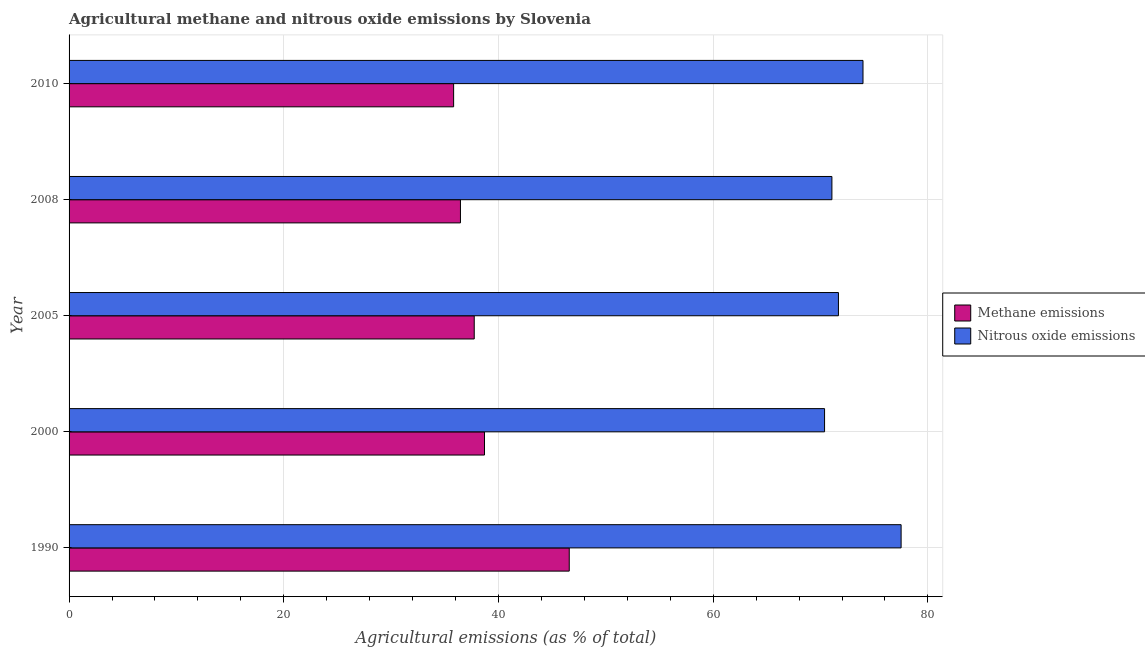How many different coloured bars are there?
Your answer should be very brief. 2. How many groups of bars are there?
Your answer should be compact. 5. Are the number of bars per tick equal to the number of legend labels?
Your answer should be compact. Yes. Are the number of bars on each tick of the Y-axis equal?
Make the answer very short. Yes. How many bars are there on the 2nd tick from the bottom?
Your answer should be compact. 2. What is the amount of methane emissions in 2005?
Make the answer very short. 37.74. Across all years, what is the maximum amount of methane emissions?
Offer a terse response. 46.59. Across all years, what is the minimum amount of nitrous oxide emissions?
Your response must be concise. 70.37. In which year was the amount of methane emissions maximum?
Ensure brevity in your answer.  1990. In which year was the amount of nitrous oxide emissions minimum?
Make the answer very short. 2000. What is the total amount of methane emissions in the graph?
Ensure brevity in your answer.  195.3. What is the difference between the amount of nitrous oxide emissions in 2000 and that in 2008?
Ensure brevity in your answer.  -0.69. What is the difference between the amount of nitrous oxide emissions in 2005 and the amount of methane emissions in 2008?
Keep it short and to the point. 35.21. What is the average amount of nitrous oxide emissions per year?
Give a very brief answer. 72.91. In the year 2000, what is the difference between the amount of methane emissions and amount of nitrous oxide emissions?
Ensure brevity in your answer.  -31.68. What is the ratio of the amount of methane emissions in 1990 to that in 2010?
Give a very brief answer. 1.3. What is the difference between the highest and the second highest amount of nitrous oxide emissions?
Keep it short and to the point. 3.55. What is the difference between the highest and the lowest amount of methane emissions?
Provide a succinct answer. 10.77. What does the 1st bar from the top in 1990 represents?
Your response must be concise. Nitrous oxide emissions. What does the 1st bar from the bottom in 2008 represents?
Keep it short and to the point. Methane emissions. How many years are there in the graph?
Provide a succinct answer. 5. What is the difference between two consecutive major ticks on the X-axis?
Provide a succinct answer. 20. Are the values on the major ticks of X-axis written in scientific E-notation?
Provide a succinct answer. No. Does the graph contain any zero values?
Provide a succinct answer. No. Where does the legend appear in the graph?
Your answer should be compact. Center right. How many legend labels are there?
Your response must be concise. 2. What is the title of the graph?
Keep it short and to the point. Agricultural methane and nitrous oxide emissions by Slovenia. Does "Register a business" appear as one of the legend labels in the graph?
Ensure brevity in your answer.  No. What is the label or title of the X-axis?
Offer a very short reply. Agricultural emissions (as % of total). What is the Agricultural emissions (as % of total) of Methane emissions in 1990?
Keep it short and to the point. 46.59. What is the Agricultural emissions (as % of total) in Nitrous oxide emissions in 1990?
Your answer should be compact. 77.5. What is the Agricultural emissions (as % of total) of Methane emissions in 2000?
Your response must be concise. 38.7. What is the Agricultural emissions (as % of total) of Nitrous oxide emissions in 2000?
Offer a very short reply. 70.37. What is the Agricultural emissions (as % of total) in Methane emissions in 2005?
Your answer should be very brief. 37.74. What is the Agricultural emissions (as % of total) in Nitrous oxide emissions in 2005?
Offer a very short reply. 71.67. What is the Agricultural emissions (as % of total) of Methane emissions in 2008?
Give a very brief answer. 36.46. What is the Agricultural emissions (as % of total) of Nitrous oxide emissions in 2008?
Your answer should be very brief. 71.06. What is the Agricultural emissions (as % of total) of Methane emissions in 2010?
Provide a short and direct response. 35.82. What is the Agricultural emissions (as % of total) of Nitrous oxide emissions in 2010?
Make the answer very short. 73.95. Across all years, what is the maximum Agricultural emissions (as % of total) of Methane emissions?
Your answer should be very brief. 46.59. Across all years, what is the maximum Agricultural emissions (as % of total) of Nitrous oxide emissions?
Keep it short and to the point. 77.5. Across all years, what is the minimum Agricultural emissions (as % of total) in Methane emissions?
Your response must be concise. 35.82. Across all years, what is the minimum Agricultural emissions (as % of total) in Nitrous oxide emissions?
Ensure brevity in your answer.  70.37. What is the total Agricultural emissions (as % of total) of Methane emissions in the graph?
Provide a short and direct response. 195.3. What is the total Agricultural emissions (as % of total) in Nitrous oxide emissions in the graph?
Offer a terse response. 364.55. What is the difference between the Agricultural emissions (as % of total) in Methane emissions in 1990 and that in 2000?
Your answer should be very brief. 7.89. What is the difference between the Agricultural emissions (as % of total) of Nitrous oxide emissions in 1990 and that in 2000?
Offer a very short reply. 7.13. What is the difference between the Agricultural emissions (as % of total) of Methane emissions in 1990 and that in 2005?
Provide a succinct answer. 8.85. What is the difference between the Agricultural emissions (as % of total) in Nitrous oxide emissions in 1990 and that in 2005?
Ensure brevity in your answer.  5.84. What is the difference between the Agricultural emissions (as % of total) of Methane emissions in 1990 and that in 2008?
Provide a succinct answer. 10.13. What is the difference between the Agricultural emissions (as % of total) in Nitrous oxide emissions in 1990 and that in 2008?
Provide a succinct answer. 6.45. What is the difference between the Agricultural emissions (as % of total) of Methane emissions in 1990 and that in 2010?
Offer a terse response. 10.77. What is the difference between the Agricultural emissions (as % of total) in Nitrous oxide emissions in 1990 and that in 2010?
Offer a very short reply. 3.55. What is the difference between the Agricultural emissions (as % of total) in Methane emissions in 2000 and that in 2005?
Offer a terse response. 0.96. What is the difference between the Agricultural emissions (as % of total) in Nitrous oxide emissions in 2000 and that in 2005?
Offer a terse response. -1.29. What is the difference between the Agricultural emissions (as % of total) of Methane emissions in 2000 and that in 2008?
Give a very brief answer. 2.24. What is the difference between the Agricultural emissions (as % of total) of Nitrous oxide emissions in 2000 and that in 2008?
Offer a very short reply. -0.68. What is the difference between the Agricultural emissions (as % of total) in Methane emissions in 2000 and that in 2010?
Provide a succinct answer. 2.88. What is the difference between the Agricultural emissions (as % of total) of Nitrous oxide emissions in 2000 and that in 2010?
Give a very brief answer. -3.58. What is the difference between the Agricultural emissions (as % of total) of Methane emissions in 2005 and that in 2008?
Keep it short and to the point. 1.28. What is the difference between the Agricultural emissions (as % of total) of Nitrous oxide emissions in 2005 and that in 2008?
Your answer should be very brief. 0.61. What is the difference between the Agricultural emissions (as % of total) in Methane emissions in 2005 and that in 2010?
Make the answer very short. 1.92. What is the difference between the Agricultural emissions (as % of total) of Nitrous oxide emissions in 2005 and that in 2010?
Your answer should be compact. -2.29. What is the difference between the Agricultural emissions (as % of total) of Methane emissions in 2008 and that in 2010?
Keep it short and to the point. 0.64. What is the difference between the Agricultural emissions (as % of total) of Nitrous oxide emissions in 2008 and that in 2010?
Keep it short and to the point. -2.9. What is the difference between the Agricultural emissions (as % of total) of Methane emissions in 1990 and the Agricultural emissions (as % of total) of Nitrous oxide emissions in 2000?
Your answer should be very brief. -23.78. What is the difference between the Agricultural emissions (as % of total) in Methane emissions in 1990 and the Agricultural emissions (as % of total) in Nitrous oxide emissions in 2005?
Provide a succinct answer. -25.07. What is the difference between the Agricultural emissions (as % of total) in Methane emissions in 1990 and the Agricultural emissions (as % of total) in Nitrous oxide emissions in 2008?
Ensure brevity in your answer.  -24.47. What is the difference between the Agricultural emissions (as % of total) of Methane emissions in 1990 and the Agricultural emissions (as % of total) of Nitrous oxide emissions in 2010?
Your answer should be very brief. -27.36. What is the difference between the Agricultural emissions (as % of total) of Methane emissions in 2000 and the Agricultural emissions (as % of total) of Nitrous oxide emissions in 2005?
Your answer should be compact. -32.97. What is the difference between the Agricultural emissions (as % of total) in Methane emissions in 2000 and the Agricultural emissions (as % of total) in Nitrous oxide emissions in 2008?
Keep it short and to the point. -32.36. What is the difference between the Agricultural emissions (as % of total) in Methane emissions in 2000 and the Agricultural emissions (as % of total) in Nitrous oxide emissions in 2010?
Provide a succinct answer. -35.26. What is the difference between the Agricultural emissions (as % of total) of Methane emissions in 2005 and the Agricultural emissions (as % of total) of Nitrous oxide emissions in 2008?
Offer a very short reply. -33.32. What is the difference between the Agricultural emissions (as % of total) of Methane emissions in 2005 and the Agricultural emissions (as % of total) of Nitrous oxide emissions in 2010?
Keep it short and to the point. -36.21. What is the difference between the Agricultural emissions (as % of total) of Methane emissions in 2008 and the Agricultural emissions (as % of total) of Nitrous oxide emissions in 2010?
Offer a very short reply. -37.5. What is the average Agricultural emissions (as % of total) in Methane emissions per year?
Make the answer very short. 39.06. What is the average Agricultural emissions (as % of total) in Nitrous oxide emissions per year?
Your answer should be compact. 72.91. In the year 1990, what is the difference between the Agricultural emissions (as % of total) of Methane emissions and Agricultural emissions (as % of total) of Nitrous oxide emissions?
Offer a very short reply. -30.91. In the year 2000, what is the difference between the Agricultural emissions (as % of total) in Methane emissions and Agricultural emissions (as % of total) in Nitrous oxide emissions?
Your answer should be very brief. -31.68. In the year 2005, what is the difference between the Agricultural emissions (as % of total) of Methane emissions and Agricultural emissions (as % of total) of Nitrous oxide emissions?
Provide a succinct answer. -33.93. In the year 2008, what is the difference between the Agricultural emissions (as % of total) of Methane emissions and Agricultural emissions (as % of total) of Nitrous oxide emissions?
Offer a very short reply. -34.6. In the year 2010, what is the difference between the Agricultural emissions (as % of total) in Methane emissions and Agricultural emissions (as % of total) in Nitrous oxide emissions?
Provide a succinct answer. -38.13. What is the ratio of the Agricultural emissions (as % of total) of Methane emissions in 1990 to that in 2000?
Make the answer very short. 1.2. What is the ratio of the Agricultural emissions (as % of total) in Nitrous oxide emissions in 1990 to that in 2000?
Your response must be concise. 1.1. What is the ratio of the Agricultural emissions (as % of total) in Methane emissions in 1990 to that in 2005?
Give a very brief answer. 1.23. What is the ratio of the Agricultural emissions (as % of total) of Nitrous oxide emissions in 1990 to that in 2005?
Your response must be concise. 1.08. What is the ratio of the Agricultural emissions (as % of total) in Methane emissions in 1990 to that in 2008?
Your answer should be compact. 1.28. What is the ratio of the Agricultural emissions (as % of total) in Nitrous oxide emissions in 1990 to that in 2008?
Ensure brevity in your answer.  1.09. What is the ratio of the Agricultural emissions (as % of total) of Methane emissions in 1990 to that in 2010?
Offer a very short reply. 1.3. What is the ratio of the Agricultural emissions (as % of total) of Nitrous oxide emissions in 1990 to that in 2010?
Keep it short and to the point. 1.05. What is the ratio of the Agricultural emissions (as % of total) in Methane emissions in 2000 to that in 2005?
Make the answer very short. 1.03. What is the ratio of the Agricultural emissions (as % of total) of Methane emissions in 2000 to that in 2008?
Offer a terse response. 1.06. What is the ratio of the Agricultural emissions (as % of total) in Methane emissions in 2000 to that in 2010?
Give a very brief answer. 1.08. What is the ratio of the Agricultural emissions (as % of total) in Nitrous oxide emissions in 2000 to that in 2010?
Your answer should be very brief. 0.95. What is the ratio of the Agricultural emissions (as % of total) in Methane emissions in 2005 to that in 2008?
Offer a terse response. 1.04. What is the ratio of the Agricultural emissions (as % of total) of Nitrous oxide emissions in 2005 to that in 2008?
Your answer should be compact. 1.01. What is the ratio of the Agricultural emissions (as % of total) in Methane emissions in 2005 to that in 2010?
Make the answer very short. 1.05. What is the ratio of the Agricultural emissions (as % of total) in Nitrous oxide emissions in 2005 to that in 2010?
Give a very brief answer. 0.97. What is the ratio of the Agricultural emissions (as % of total) of Methane emissions in 2008 to that in 2010?
Ensure brevity in your answer.  1.02. What is the ratio of the Agricultural emissions (as % of total) in Nitrous oxide emissions in 2008 to that in 2010?
Give a very brief answer. 0.96. What is the difference between the highest and the second highest Agricultural emissions (as % of total) in Methane emissions?
Provide a succinct answer. 7.89. What is the difference between the highest and the second highest Agricultural emissions (as % of total) in Nitrous oxide emissions?
Keep it short and to the point. 3.55. What is the difference between the highest and the lowest Agricultural emissions (as % of total) of Methane emissions?
Make the answer very short. 10.77. What is the difference between the highest and the lowest Agricultural emissions (as % of total) in Nitrous oxide emissions?
Your response must be concise. 7.13. 